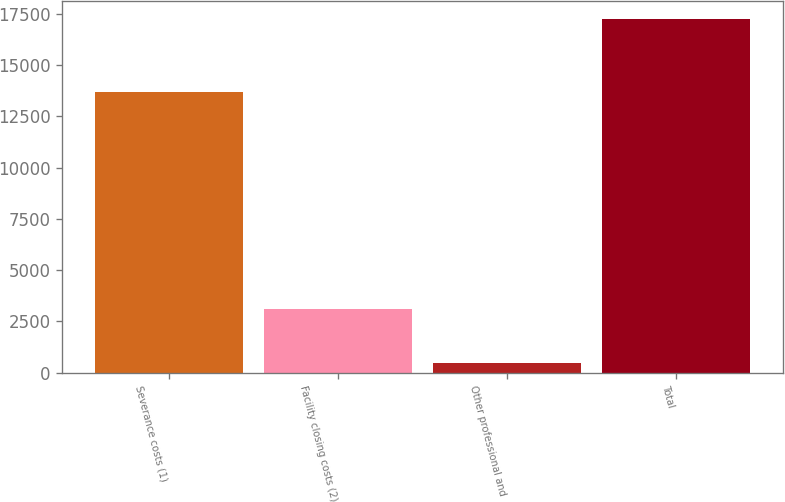<chart> <loc_0><loc_0><loc_500><loc_500><bar_chart><fcel>Severance costs (1)<fcel>Facility closing costs (2)<fcel>Other professional and<fcel>Total<nl><fcel>13697<fcel>3110<fcel>453<fcel>17260<nl></chart> 